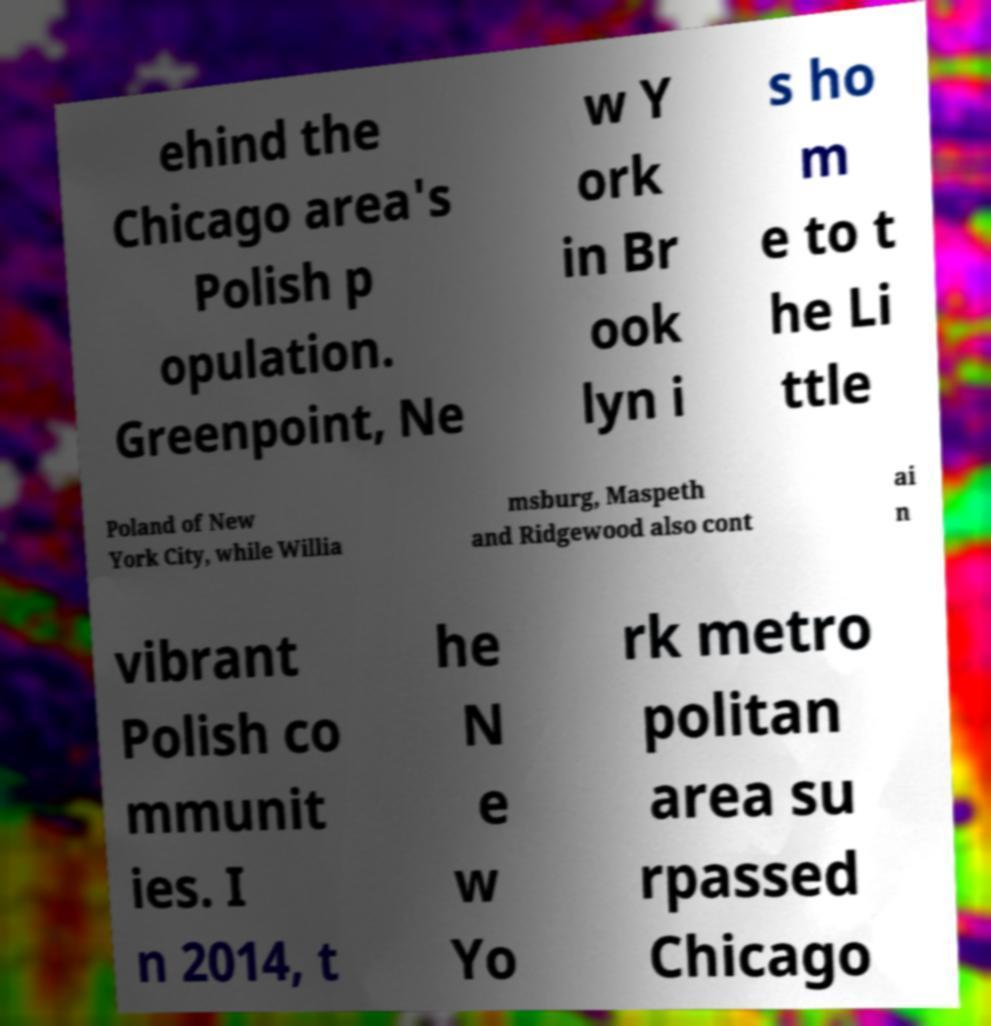Could you extract and type out the text from this image? ehind the Chicago area's Polish p opulation. Greenpoint, Ne w Y ork in Br ook lyn i s ho m e to t he Li ttle Poland of New York City, while Willia msburg, Maspeth and Ridgewood also cont ai n vibrant Polish co mmunit ies. I n 2014, t he N e w Yo rk metro politan area su rpassed Chicago 